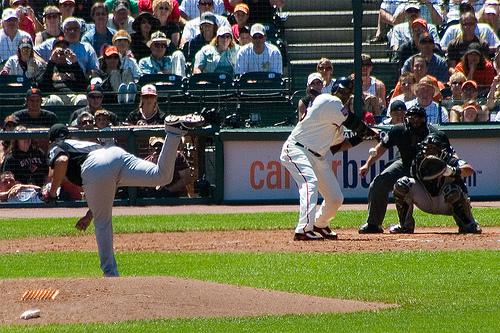Question: who will win?
Choices:
A. No one.
B. The owners.
C. One the teams.
D. The fans, who will be entertained.
Answer with the letter. Answer: C Question: where is the pitcher doing?
Choices:
A. Waiting for a signal.
B. Throwing the ball.
C. Striking out the batter.
D. Spitting.
Answer with the letter. Answer: B Question: when will the game start?
Choices:
A. After the rain.
B. Soon as they play.
C. 12:05.
D. When the teams arrive.
Answer with the letter. Answer: B Question: what do the man have in his hand?
Choices:
A. A bat.
B. A ball.
C. A compass.
D. Chalk.
Answer with the letter. Answer: A Question: what kind of game they playing?
Choices:
A. Baseball game.
B. Tennis game.
C. Home run derby.
D. Mind game.
Answer with the letter. Answer: A Question: what color is the grass?
Choices:
A. A nice green.
B. Yellow.
C. Brown.
D. Blue.
Answer with the letter. Answer: A Question: why are the people sitting on the bleaches?
Choices:
A. The other chairs are full.
B. They want a sore back.
C. For the game.
D. Good view.
Answer with the letter. Answer: C 